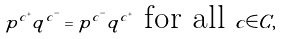<formula> <loc_0><loc_0><loc_500><loc_500>p ^ { c ^ { + } } q ^ { c ^ { - } } = p ^ { c ^ { - } } q ^ { c ^ { + } } \text { for all } c \in C ,</formula> 